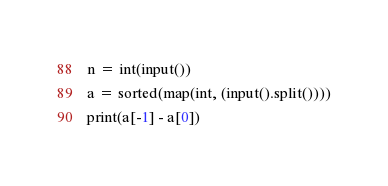Convert code to text. <code><loc_0><loc_0><loc_500><loc_500><_Python_>n = int(input())
a = sorted(map(int, (input().split())))
print(a[-1] - a[0])
</code> 